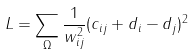Convert formula to latex. <formula><loc_0><loc_0><loc_500><loc_500>L = \sum _ { \Omega } \frac { 1 } { w _ { i j } ^ { 2 } } ( c _ { i j } + d _ { i } - d _ { j } ) ^ { 2 }</formula> 